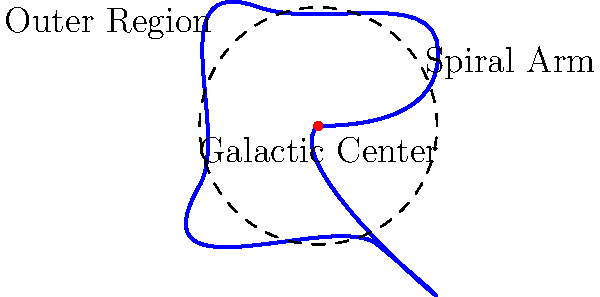In the diagram representing our galaxy, the Milky Way, which part is most likely to contain the highest concentration of young, newly formed stars? To answer this question, let's consider the structure of our galaxy:

1. The Milky Way is a spiral galaxy, as shown in the diagram.
2. Spiral galaxies have distinct regions:
   a. The galactic center (marked by the red dot)
   b. Spiral arms (the curved blue lines)
   c. Outer regions (the areas between and beyond the spiral arms)

3. Star formation in spiral galaxies:
   a. Spiral arms contain dense clouds of gas and dust.
   b. These clouds are the primary sites of star formation.
   c. The compression of gas in spiral arms triggers the birth of new stars.

4. Age distribution of stars:
   a. Younger stars are found more commonly in spiral arms.
   b. Older stars are more evenly distributed throughout the galaxy.

5. Concentration of young stars:
   a. The highest concentration of young, newly formed stars is typically found in the spiral arms.
   b. This is due to the ongoing star formation processes in these regions.

Therefore, based on our understanding of galactic structure and star formation, the spiral arms are most likely to contain the highest concentration of young, newly formed stars.
Answer: Spiral arms 